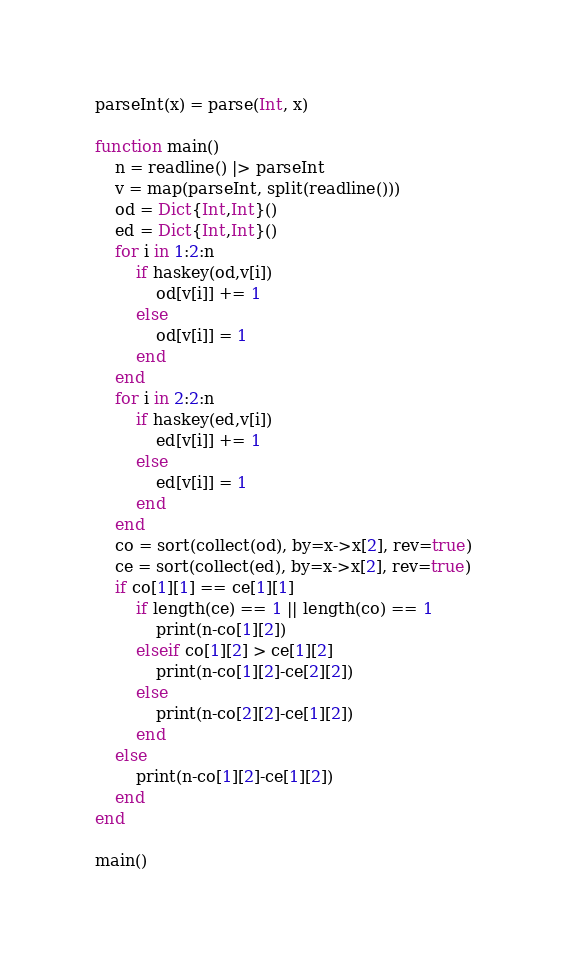<code> <loc_0><loc_0><loc_500><loc_500><_Julia_>parseInt(x) = parse(Int, x)

function main()
	n = readline() |> parseInt
	v = map(parseInt, split(readline()))
	od = Dict{Int,Int}()
	ed = Dict{Int,Int}()
	for i in 1:2:n
		if haskey(od,v[i])
			od[v[i]] += 1
		else
			od[v[i]] = 1
		end
	end
	for i in 2:2:n
		if haskey(ed,v[i])
			ed[v[i]] += 1
		else
			ed[v[i]] = 1
		end
	end
	co = sort(collect(od), by=x->x[2], rev=true)
	ce = sort(collect(ed), by=x->x[2], rev=true)
	if co[1][1] == ce[1][1]
		if length(ce) == 1 || length(co) == 1
			print(n-co[1][2])
		elseif co[1][2] > ce[1][2]
			print(n-co[1][2]-ce[2][2])
		else
			print(n-co[2][2]-ce[1][2])
		end
	else
		print(n-co[1][2]-ce[1][2])
	end
end

main()</code> 